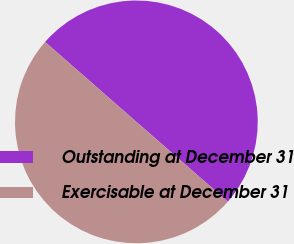Convert chart to OTSL. <chart><loc_0><loc_0><loc_500><loc_500><pie_chart><fcel>Outstanding at December 31<fcel>Exercisable at December 31<nl><fcel>49.97%<fcel>50.03%<nl></chart> 